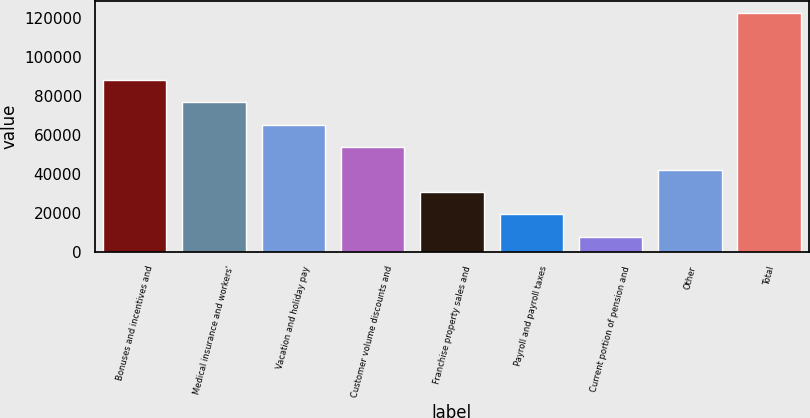Convert chart. <chart><loc_0><loc_0><loc_500><loc_500><bar_chart><fcel>Bonuses and incentives and<fcel>Medical insurance and workers'<fcel>Vacation and holiday pay<fcel>Customer volume discounts and<fcel>Franchise property sales and<fcel>Payroll and payroll taxes<fcel>Current portion of pension and<fcel>Other<fcel>Total<nl><fcel>88174.1<fcel>76666.8<fcel>65159.5<fcel>53652.2<fcel>30637.6<fcel>19130.3<fcel>7623<fcel>42144.9<fcel>122696<nl></chart> 